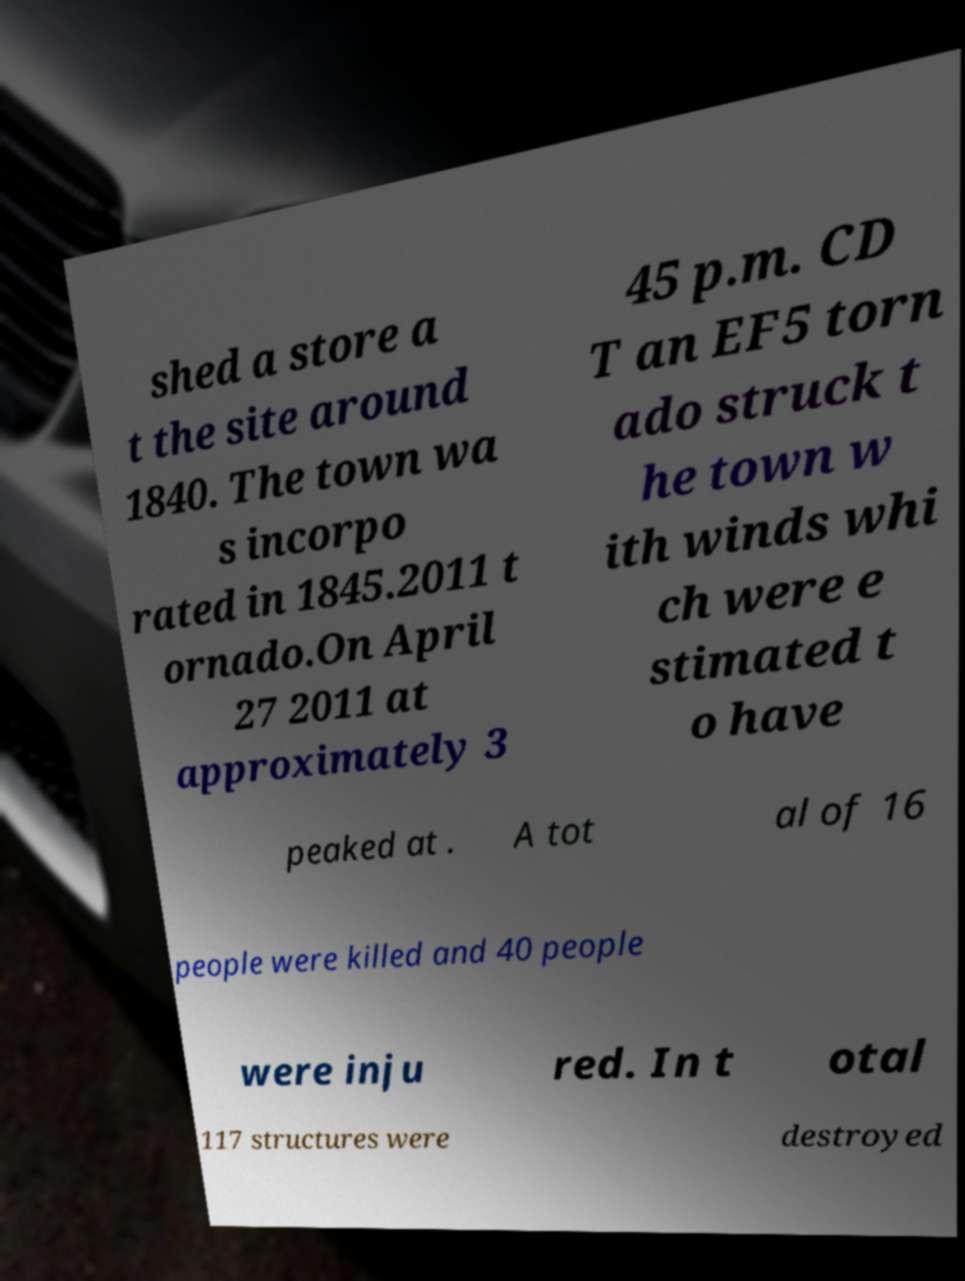Can you read and provide the text displayed in the image?This photo seems to have some interesting text. Can you extract and type it out for me? shed a store a t the site around 1840. The town wa s incorpo rated in 1845.2011 t ornado.On April 27 2011 at approximately 3 45 p.m. CD T an EF5 torn ado struck t he town w ith winds whi ch were e stimated t o have peaked at . A tot al of 16 people were killed and 40 people were inju red. In t otal 117 structures were destroyed 